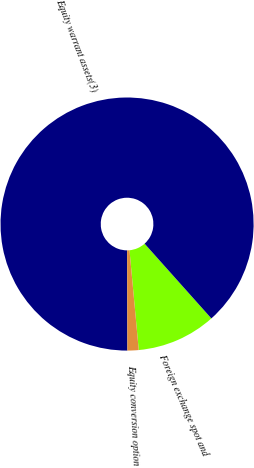Convert chart to OTSL. <chart><loc_0><loc_0><loc_500><loc_500><pie_chart><fcel>Foreign exchange spot and<fcel>Equity warrant assets(3)<fcel>Equity conversion option<nl><fcel>10.13%<fcel>88.43%<fcel>1.43%<nl></chart> 